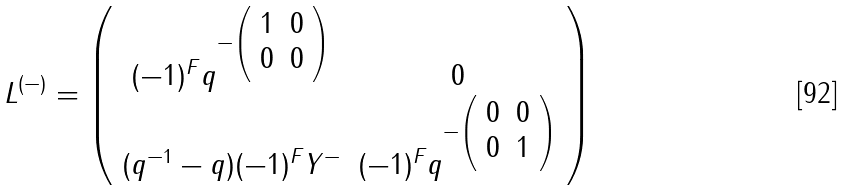Convert formula to latex. <formula><loc_0><loc_0><loc_500><loc_500>L ^ { ( - ) } = \left ( \begin{array} { c c } { { ( - 1 ) ^ { F } q ^ { - \left ( \begin{array} { c c } { 1 } & { 0 } \\ { 0 } & { 0 } \end{array} \right ) } } } & { 0 } \\ { { ( q ^ { - 1 } - q ) ( - 1 ) ^ { F } Y ^ { - } } } & { { ( - 1 ) ^ { F } q ^ { - \left ( \begin{array} { c c } { 0 } & { 0 } \\ { 0 } & { 1 } \end{array} \right ) } } } \end{array} \right )</formula> 